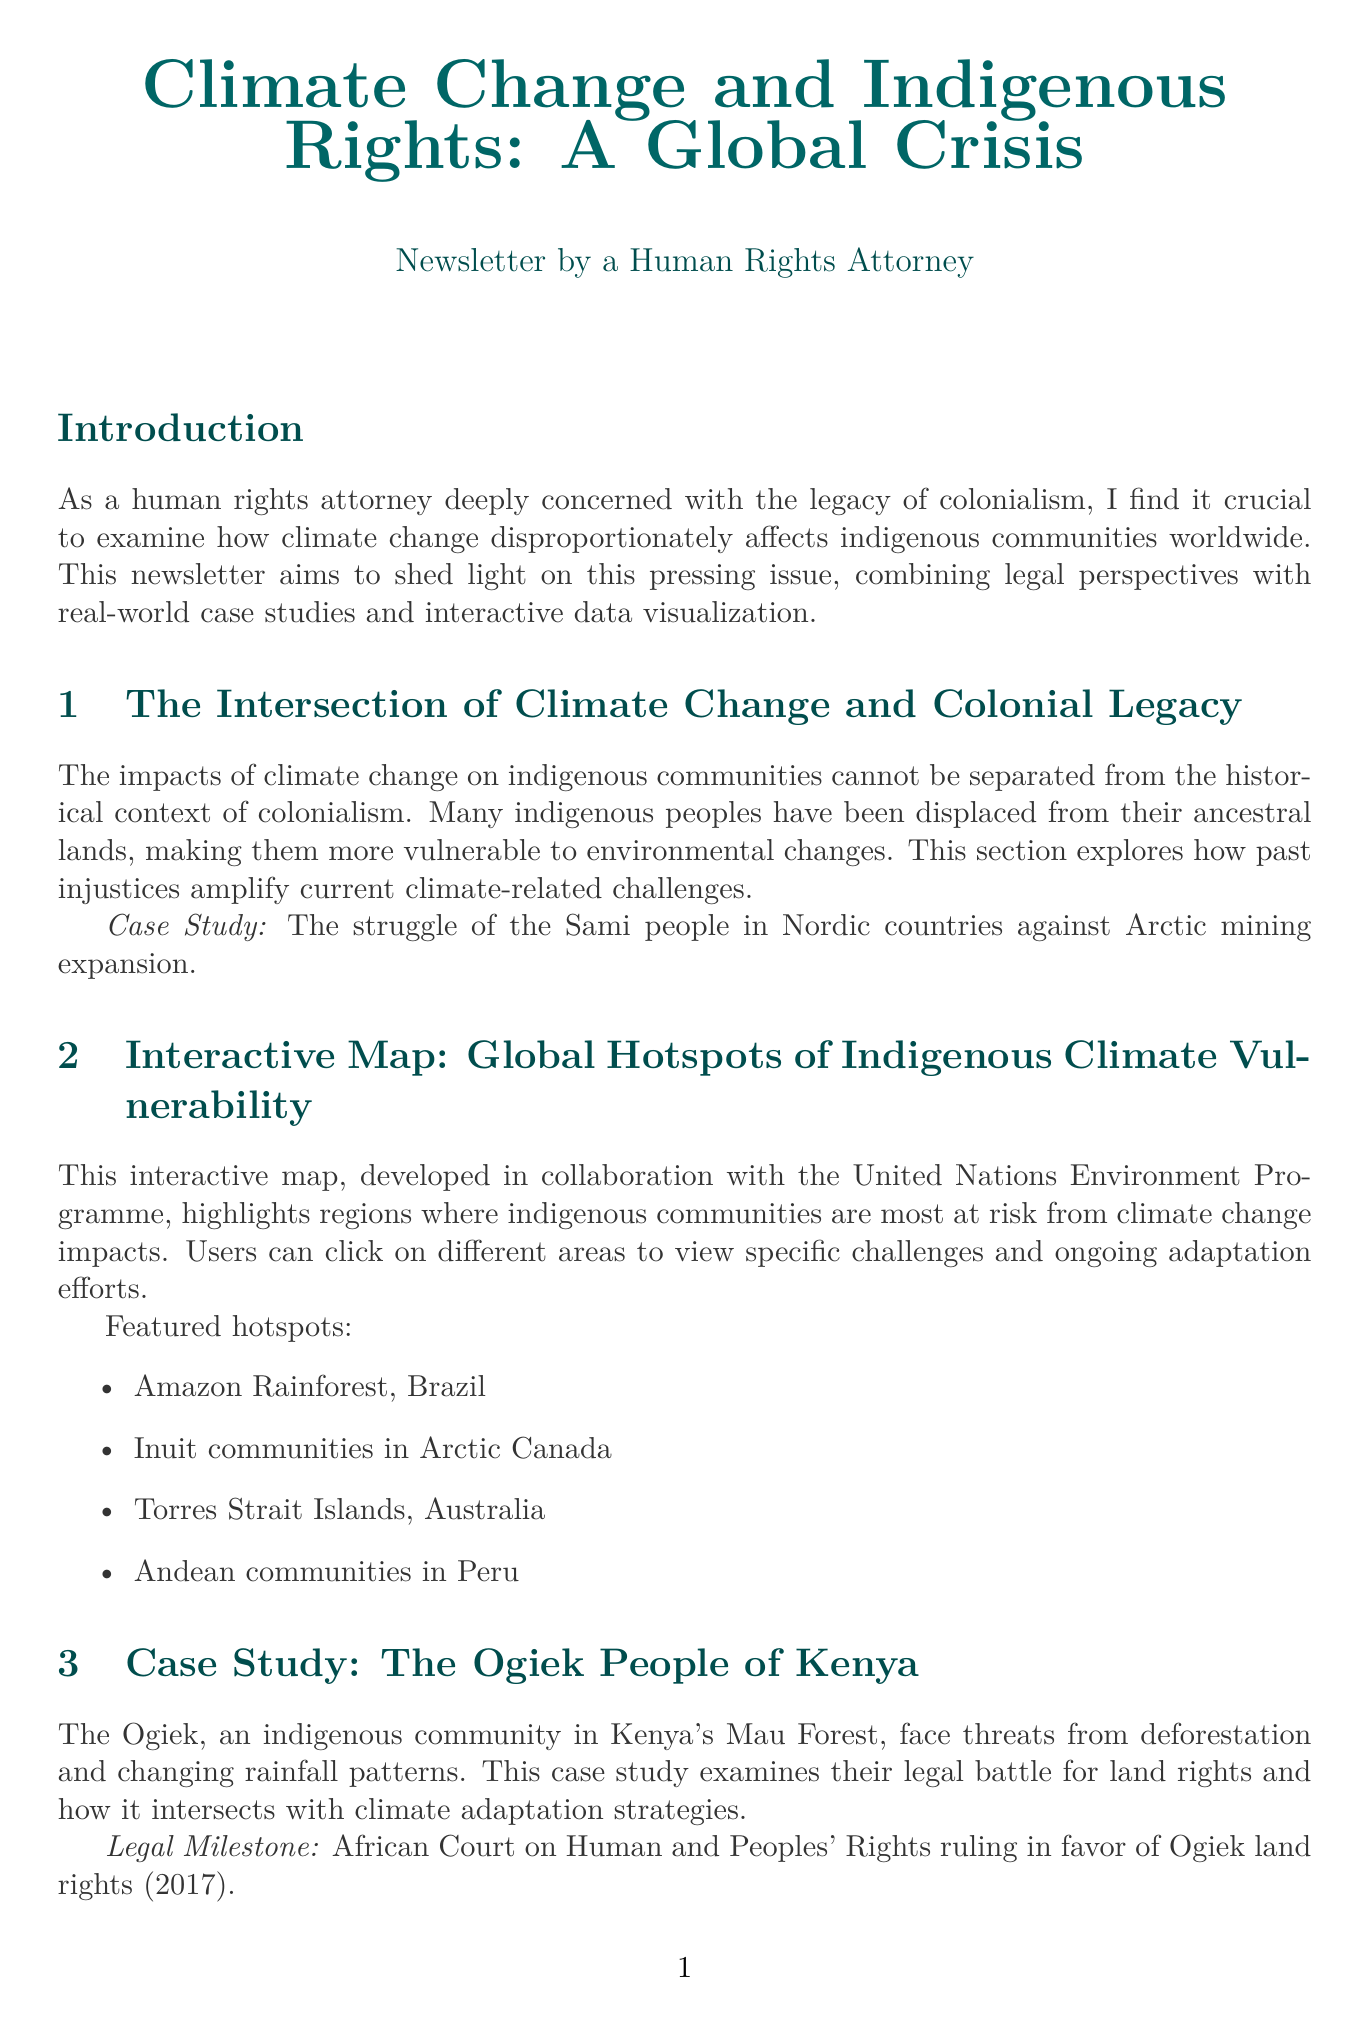What is the title of the newsletter? The title is presented at the top of the document and summarizes the main theme of the publication.
Answer: Climate Change and Indigenous Rights: A Global Crisis What is the legal milestone for the Ogiek people? This specific legal milestone illustrates a significant event affecting the Ogiek community's land rights and climate adaptation.
Answer: African Court on Human and Peoples' Rights ruling in favor of Ogiek land rights (2017) Name one featured hotspot on the interactive map. This question asks for specific information about the locations highlighted in the document as vulnerable to climate change.
Answer: Amazon Rainforest, Brazil What traditional technique are Quechua farmers using? The answer relates to indigenous knowledge being employed for climate adaptation, as described in the document.
Answer: Traditional agricultural techniques Which organization is featured in the call to action? The document includes a section that encourages support for a specific organization focused on indigenous climate initiatives.
Answer: Indigenous Environmental Network What year was the Escazú Agreement established? This requires knowledge of the specific legal document mentioned in the newsletter that supports indigenous rights.
Answer: 2018 